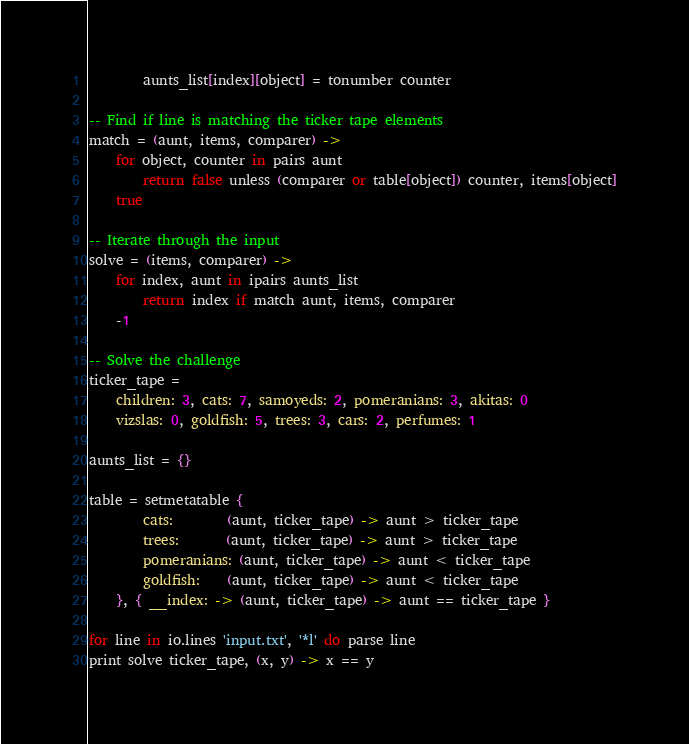<code> <loc_0><loc_0><loc_500><loc_500><_MoonScript_>        aunts_list[index][object] = tonumber counter

-- Find if line is matching the ticker tape elements
match = (aunt, items, comparer) ->
    for object, counter in pairs aunt
        return false unless (comparer or table[object]) counter, items[object]
    true

-- Iterate through the input
solve = (items, comparer) ->
    for index, aunt in ipairs aunts_list
        return index if match aunt, items, comparer
    -1

-- Solve the challenge
ticker_tape =
    children: 3, cats: 7, samoyeds: 2, pomeranians: 3, akitas: 0
    vizslas: 0, goldfish: 5, trees: 3, cars: 2, perfumes: 1

aunts_list = {}

table = setmetatable {
        cats:        (aunt, ticker_tape) -> aunt > ticker_tape
        trees:       (aunt, ticker_tape) -> aunt > ticker_tape
        pomeranians: (aunt, ticker_tape) -> aunt < ticker_tape
        goldfish:    (aunt, ticker_tape) -> aunt < ticker_tape
    }, { __index: -> (aunt, ticker_tape) -> aunt == ticker_tape }

for line in io.lines 'input.txt', '*l' do parse line
print solve ticker_tape, (x, y) -> x == y
</code> 